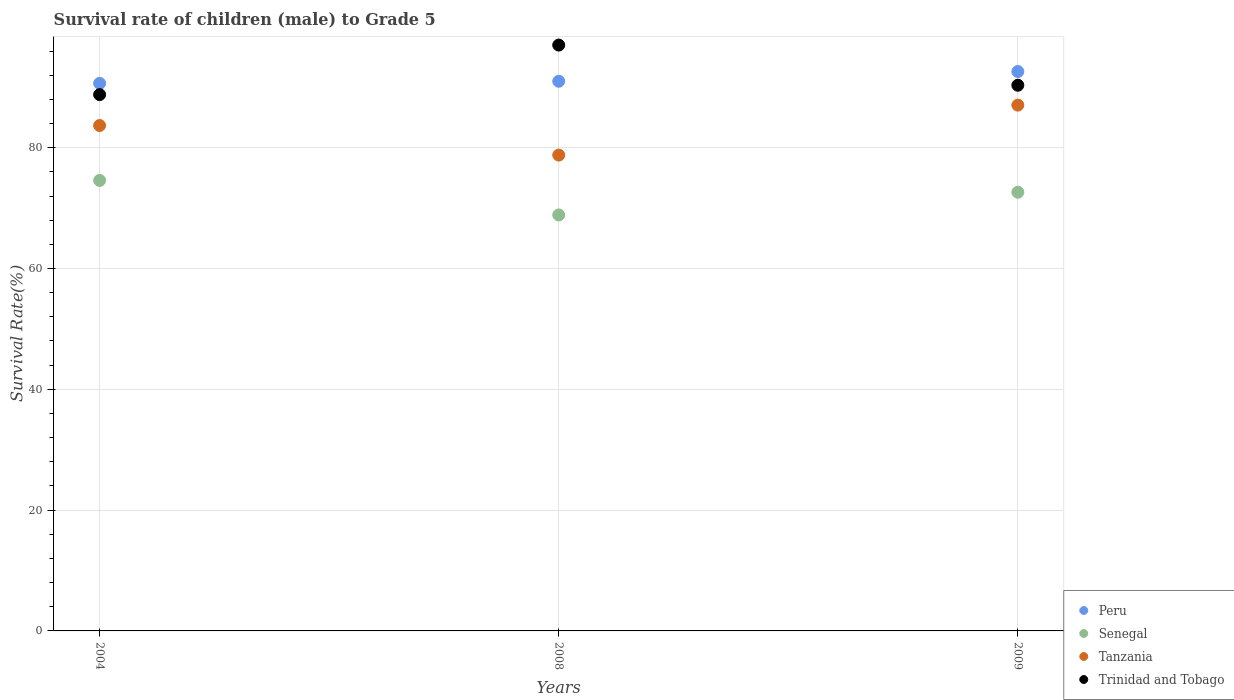Is the number of dotlines equal to the number of legend labels?
Your answer should be very brief. Yes. What is the survival rate of male children to grade 5 in Tanzania in 2004?
Your response must be concise. 83.67. Across all years, what is the maximum survival rate of male children to grade 5 in Peru?
Provide a succinct answer. 92.61. Across all years, what is the minimum survival rate of male children to grade 5 in Tanzania?
Give a very brief answer. 78.78. In which year was the survival rate of male children to grade 5 in Tanzania minimum?
Ensure brevity in your answer.  2008. What is the total survival rate of male children to grade 5 in Senegal in the graph?
Offer a terse response. 216.08. What is the difference between the survival rate of male children to grade 5 in Tanzania in 2004 and that in 2008?
Provide a succinct answer. 4.89. What is the difference between the survival rate of male children to grade 5 in Tanzania in 2008 and the survival rate of male children to grade 5 in Senegal in 2009?
Keep it short and to the point. 6.15. What is the average survival rate of male children to grade 5 in Peru per year?
Give a very brief answer. 91.42. In the year 2004, what is the difference between the survival rate of male children to grade 5 in Tanzania and survival rate of male children to grade 5 in Peru?
Provide a succinct answer. -6.98. What is the ratio of the survival rate of male children to grade 5 in Tanzania in 2004 to that in 2008?
Your answer should be compact. 1.06. Is the difference between the survival rate of male children to grade 5 in Tanzania in 2008 and 2009 greater than the difference between the survival rate of male children to grade 5 in Peru in 2008 and 2009?
Keep it short and to the point. No. What is the difference between the highest and the second highest survival rate of male children to grade 5 in Tanzania?
Provide a succinct answer. 3.37. What is the difference between the highest and the lowest survival rate of male children to grade 5 in Peru?
Give a very brief answer. 1.96. Is the sum of the survival rate of male children to grade 5 in Peru in 2008 and 2009 greater than the maximum survival rate of male children to grade 5 in Trinidad and Tobago across all years?
Offer a very short reply. Yes. Is it the case that in every year, the sum of the survival rate of male children to grade 5 in Trinidad and Tobago and survival rate of male children to grade 5 in Senegal  is greater than the sum of survival rate of male children to grade 5 in Tanzania and survival rate of male children to grade 5 in Peru?
Provide a succinct answer. No. Is it the case that in every year, the sum of the survival rate of male children to grade 5 in Peru and survival rate of male children to grade 5 in Tanzania  is greater than the survival rate of male children to grade 5 in Trinidad and Tobago?
Your answer should be very brief. Yes. Does the survival rate of male children to grade 5 in Trinidad and Tobago monotonically increase over the years?
Offer a very short reply. No. Is the survival rate of male children to grade 5 in Peru strictly less than the survival rate of male children to grade 5 in Tanzania over the years?
Your response must be concise. No. What is the difference between two consecutive major ticks on the Y-axis?
Your answer should be compact. 20. Where does the legend appear in the graph?
Make the answer very short. Bottom right. How many legend labels are there?
Your answer should be very brief. 4. What is the title of the graph?
Offer a very short reply. Survival rate of children (male) to Grade 5. What is the label or title of the X-axis?
Provide a short and direct response. Years. What is the label or title of the Y-axis?
Your answer should be very brief. Survival Rate(%). What is the Survival Rate(%) of Peru in 2004?
Offer a terse response. 90.65. What is the Survival Rate(%) of Senegal in 2004?
Your answer should be compact. 74.58. What is the Survival Rate(%) of Tanzania in 2004?
Offer a very short reply. 83.67. What is the Survival Rate(%) in Trinidad and Tobago in 2004?
Keep it short and to the point. 88.78. What is the Survival Rate(%) of Peru in 2008?
Offer a terse response. 91. What is the Survival Rate(%) in Senegal in 2008?
Your answer should be very brief. 68.87. What is the Survival Rate(%) in Tanzania in 2008?
Your answer should be very brief. 78.78. What is the Survival Rate(%) of Trinidad and Tobago in 2008?
Your answer should be compact. 96.99. What is the Survival Rate(%) of Peru in 2009?
Ensure brevity in your answer.  92.61. What is the Survival Rate(%) of Senegal in 2009?
Keep it short and to the point. 72.63. What is the Survival Rate(%) in Tanzania in 2009?
Provide a short and direct response. 87.04. What is the Survival Rate(%) in Trinidad and Tobago in 2009?
Your response must be concise. 90.34. Across all years, what is the maximum Survival Rate(%) in Peru?
Offer a very short reply. 92.61. Across all years, what is the maximum Survival Rate(%) of Senegal?
Your response must be concise. 74.58. Across all years, what is the maximum Survival Rate(%) of Tanzania?
Keep it short and to the point. 87.04. Across all years, what is the maximum Survival Rate(%) of Trinidad and Tobago?
Offer a terse response. 96.99. Across all years, what is the minimum Survival Rate(%) of Peru?
Keep it short and to the point. 90.65. Across all years, what is the minimum Survival Rate(%) in Senegal?
Your response must be concise. 68.87. Across all years, what is the minimum Survival Rate(%) of Tanzania?
Your response must be concise. 78.78. Across all years, what is the minimum Survival Rate(%) in Trinidad and Tobago?
Your answer should be very brief. 88.78. What is the total Survival Rate(%) of Peru in the graph?
Offer a terse response. 274.26. What is the total Survival Rate(%) of Senegal in the graph?
Provide a succinct answer. 216.08. What is the total Survival Rate(%) in Tanzania in the graph?
Make the answer very short. 249.49. What is the total Survival Rate(%) in Trinidad and Tobago in the graph?
Keep it short and to the point. 276.11. What is the difference between the Survival Rate(%) of Peru in 2004 and that in 2008?
Provide a succinct answer. -0.34. What is the difference between the Survival Rate(%) of Senegal in 2004 and that in 2008?
Provide a short and direct response. 5.72. What is the difference between the Survival Rate(%) of Tanzania in 2004 and that in 2008?
Give a very brief answer. 4.89. What is the difference between the Survival Rate(%) of Trinidad and Tobago in 2004 and that in 2008?
Ensure brevity in your answer.  -8.2. What is the difference between the Survival Rate(%) in Peru in 2004 and that in 2009?
Offer a terse response. -1.96. What is the difference between the Survival Rate(%) in Senegal in 2004 and that in 2009?
Give a very brief answer. 1.95. What is the difference between the Survival Rate(%) in Tanzania in 2004 and that in 2009?
Your answer should be very brief. -3.37. What is the difference between the Survival Rate(%) of Trinidad and Tobago in 2004 and that in 2009?
Keep it short and to the point. -1.56. What is the difference between the Survival Rate(%) in Peru in 2008 and that in 2009?
Make the answer very short. -1.61. What is the difference between the Survival Rate(%) of Senegal in 2008 and that in 2009?
Provide a short and direct response. -3.76. What is the difference between the Survival Rate(%) of Tanzania in 2008 and that in 2009?
Give a very brief answer. -8.27. What is the difference between the Survival Rate(%) of Trinidad and Tobago in 2008 and that in 2009?
Keep it short and to the point. 6.65. What is the difference between the Survival Rate(%) in Peru in 2004 and the Survival Rate(%) in Senegal in 2008?
Your response must be concise. 21.79. What is the difference between the Survival Rate(%) of Peru in 2004 and the Survival Rate(%) of Tanzania in 2008?
Your answer should be compact. 11.88. What is the difference between the Survival Rate(%) of Peru in 2004 and the Survival Rate(%) of Trinidad and Tobago in 2008?
Give a very brief answer. -6.34. What is the difference between the Survival Rate(%) of Senegal in 2004 and the Survival Rate(%) of Tanzania in 2008?
Your answer should be very brief. -4.19. What is the difference between the Survival Rate(%) in Senegal in 2004 and the Survival Rate(%) in Trinidad and Tobago in 2008?
Make the answer very short. -22.41. What is the difference between the Survival Rate(%) of Tanzania in 2004 and the Survival Rate(%) of Trinidad and Tobago in 2008?
Provide a short and direct response. -13.32. What is the difference between the Survival Rate(%) in Peru in 2004 and the Survival Rate(%) in Senegal in 2009?
Your answer should be very brief. 18.03. What is the difference between the Survival Rate(%) in Peru in 2004 and the Survival Rate(%) in Tanzania in 2009?
Give a very brief answer. 3.61. What is the difference between the Survival Rate(%) of Peru in 2004 and the Survival Rate(%) of Trinidad and Tobago in 2009?
Make the answer very short. 0.31. What is the difference between the Survival Rate(%) of Senegal in 2004 and the Survival Rate(%) of Tanzania in 2009?
Provide a succinct answer. -12.46. What is the difference between the Survival Rate(%) in Senegal in 2004 and the Survival Rate(%) in Trinidad and Tobago in 2009?
Offer a terse response. -15.76. What is the difference between the Survival Rate(%) in Tanzania in 2004 and the Survival Rate(%) in Trinidad and Tobago in 2009?
Keep it short and to the point. -6.67. What is the difference between the Survival Rate(%) of Peru in 2008 and the Survival Rate(%) of Senegal in 2009?
Make the answer very short. 18.37. What is the difference between the Survival Rate(%) in Peru in 2008 and the Survival Rate(%) in Tanzania in 2009?
Provide a succinct answer. 3.95. What is the difference between the Survival Rate(%) of Peru in 2008 and the Survival Rate(%) of Trinidad and Tobago in 2009?
Keep it short and to the point. 0.66. What is the difference between the Survival Rate(%) in Senegal in 2008 and the Survival Rate(%) in Tanzania in 2009?
Your answer should be compact. -18.18. What is the difference between the Survival Rate(%) of Senegal in 2008 and the Survival Rate(%) of Trinidad and Tobago in 2009?
Keep it short and to the point. -21.47. What is the difference between the Survival Rate(%) of Tanzania in 2008 and the Survival Rate(%) of Trinidad and Tobago in 2009?
Make the answer very short. -11.56. What is the average Survival Rate(%) in Peru per year?
Give a very brief answer. 91.42. What is the average Survival Rate(%) in Senegal per year?
Offer a very short reply. 72.03. What is the average Survival Rate(%) in Tanzania per year?
Ensure brevity in your answer.  83.16. What is the average Survival Rate(%) in Trinidad and Tobago per year?
Give a very brief answer. 92.04. In the year 2004, what is the difference between the Survival Rate(%) in Peru and Survival Rate(%) in Senegal?
Make the answer very short. 16.07. In the year 2004, what is the difference between the Survival Rate(%) of Peru and Survival Rate(%) of Tanzania?
Your response must be concise. 6.98. In the year 2004, what is the difference between the Survival Rate(%) in Peru and Survival Rate(%) in Trinidad and Tobago?
Your answer should be very brief. 1.87. In the year 2004, what is the difference between the Survival Rate(%) of Senegal and Survival Rate(%) of Tanzania?
Your answer should be compact. -9.09. In the year 2004, what is the difference between the Survival Rate(%) in Senegal and Survival Rate(%) in Trinidad and Tobago?
Keep it short and to the point. -14.2. In the year 2004, what is the difference between the Survival Rate(%) of Tanzania and Survival Rate(%) of Trinidad and Tobago?
Give a very brief answer. -5.11. In the year 2008, what is the difference between the Survival Rate(%) of Peru and Survival Rate(%) of Senegal?
Ensure brevity in your answer.  22.13. In the year 2008, what is the difference between the Survival Rate(%) in Peru and Survival Rate(%) in Tanzania?
Your response must be concise. 12.22. In the year 2008, what is the difference between the Survival Rate(%) of Peru and Survival Rate(%) of Trinidad and Tobago?
Give a very brief answer. -5.99. In the year 2008, what is the difference between the Survival Rate(%) in Senegal and Survival Rate(%) in Tanzania?
Keep it short and to the point. -9.91. In the year 2008, what is the difference between the Survival Rate(%) of Senegal and Survival Rate(%) of Trinidad and Tobago?
Ensure brevity in your answer.  -28.12. In the year 2008, what is the difference between the Survival Rate(%) of Tanzania and Survival Rate(%) of Trinidad and Tobago?
Ensure brevity in your answer.  -18.21. In the year 2009, what is the difference between the Survival Rate(%) in Peru and Survival Rate(%) in Senegal?
Give a very brief answer. 19.98. In the year 2009, what is the difference between the Survival Rate(%) in Peru and Survival Rate(%) in Tanzania?
Give a very brief answer. 5.56. In the year 2009, what is the difference between the Survival Rate(%) of Peru and Survival Rate(%) of Trinidad and Tobago?
Ensure brevity in your answer.  2.27. In the year 2009, what is the difference between the Survival Rate(%) of Senegal and Survival Rate(%) of Tanzania?
Your answer should be compact. -14.42. In the year 2009, what is the difference between the Survival Rate(%) of Senegal and Survival Rate(%) of Trinidad and Tobago?
Provide a short and direct response. -17.71. In the year 2009, what is the difference between the Survival Rate(%) of Tanzania and Survival Rate(%) of Trinidad and Tobago?
Your answer should be very brief. -3.3. What is the ratio of the Survival Rate(%) in Senegal in 2004 to that in 2008?
Offer a terse response. 1.08. What is the ratio of the Survival Rate(%) in Tanzania in 2004 to that in 2008?
Provide a short and direct response. 1.06. What is the ratio of the Survival Rate(%) of Trinidad and Tobago in 2004 to that in 2008?
Offer a very short reply. 0.92. What is the ratio of the Survival Rate(%) of Peru in 2004 to that in 2009?
Keep it short and to the point. 0.98. What is the ratio of the Survival Rate(%) in Senegal in 2004 to that in 2009?
Keep it short and to the point. 1.03. What is the ratio of the Survival Rate(%) of Tanzania in 2004 to that in 2009?
Offer a very short reply. 0.96. What is the ratio of the Survival Rate(%) in Trinidad and Tobago in 2004 to that in 2009?
Offer a terse response. 0.98. What is the ratio of the Survival Rate(%) in Peru in 2008 to that in 2009?
Your answer should be very brief. 0.98. What is the ratio of the Survival Rate(%) of Senegal in 2008 to that in 2009?
Offer a terse response. 0.95. What is the ratio of the Survival Rate(%) in Tanzania in 2008 to that in 2009?
Ensure brevity in your answer.  0.91. What is the ratio of the Survival Rate(%) in Trinidad and Tobago in 2008 to that in 2009?
Give a very brief answer. 1.07. What is the difference between the highest and the second highest Survival Rate(%) of Peru?
Keep it short and to the point. 1.61. What is the difference between the highest and the second highest Survival Rate(%) of Senegal?
Make the answer very short. 1.95. What is the difference between the highest and the second highest Survival Rate(%) of Tanzania?
Keep it short and to the point. 3.37. What is the difference between the highest and the second highest Survival Rate(%) in Trinidad and Tobago?
Make the answer very short. 6.65. What is the difference between the highest and the lowest Survival Rate(%) of Peru?
Offer a very short reply. 1.96. What is the difference between the highest and the lowest Survival Rate(%) of Senegal?
Give a very brief answer. 5.72. What is the difference between the highest and the lowest Survival Rate(%) of Tanzania?
Provide a succinct answer. 8.27. What is the difference between the highest and the lowest Survival Rate(%) in Trinidad and Tobago?
Your answer should be compact. 8.2. 